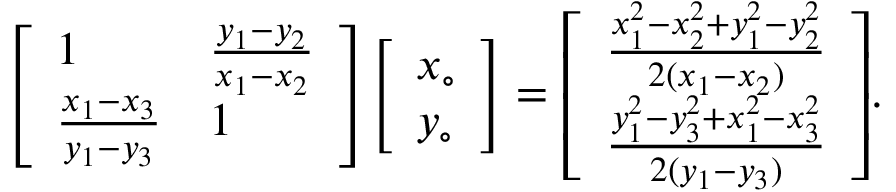Convert formula to latex. <formula><loc_0><loc_0><loc_500><loc_500>{ \left [ \begin{array} { l l } { 1 } & { { \frac { y _ { 1 } - y _ { 2 } } { x _ { 1 } - x _ { 2 } } } } \\ { { \frac { x _ { 1 } - x _ { 3 } } { y _ { 1 } - y _ { 3 } } } } & { 1 } \end{array} \right ] } { \left [ \begin{array} { l } { x _ { \circ } } \\ { y _ { \circ } } \end{array} \right ] } = { \left [ \begin{array} { l } { { \frac { x _ { 1 } ^ { 2 } - x _ { 2 } ^ { 2 } + y _ { 1 } ^ { 2 } - y _ { 2 } ^ { 2 } } { 2 ( x _ { 1 } - x _ { 2 } ) } } } \\ { { \frac { y _ { 1 } ^ { 2 } - y _ { 3 } ^ { 2 } + x _ { 1 } ^ { 2 } - x _ { 3 } ^ { 2 } } { 2 ( y _ { 1 } - y _ { 3 } ) } } } \end{array} \right ] } .</formula> 